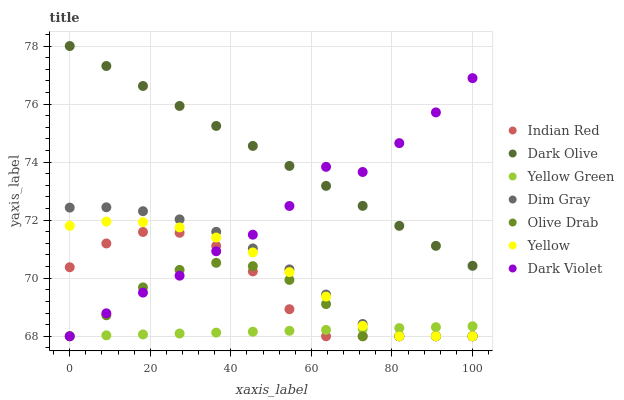Does Yellow Green have the minimum area under the curve?
Answer yes or no. Yes. Does Dark Olive have the maximum area under the curve?
Answer yes or no. Yes. Does Dark Olive have the minimum area under the curve?
Answer yes or no. No. Does Yellow Green have the maximum area under the curve?
Answer yes or no. No. Is Dark Olive the smoothest?
Answer yes or no. Yes. Is Dark Violet the roughest?
Answer yes or no. Yes. Is Yellow Green the smoothest?
Answer yes or no. No. Is Yellow Green the roughest?
Answer yes or no. No. Does Dim Gray have the lowest value?
Answer yes or no. Yes. Does Dark Olive have the lowest value?
Answer yes or no. No. Does Dark Olive have the highest value?
Answer yes or no. Yes. Does Yellow Green have the highest value?
Answer yes or no. No. Is Dim Gray less than Dark Olive?
Answer yes or no. Yes. Is Dark Olive greater than Olive Drab?
Answer yes or no. Yes. Does Yellow intersect Olive Drab?
Answer yes or no. Yes. Is Yellow less than Olive Drab?
Answer yes or no. No. Is Yellow greater than Olive Drab?
Answer yes or no. No. Does Dim Gray intersect Dark Olive?
Answer yes or no. No. 